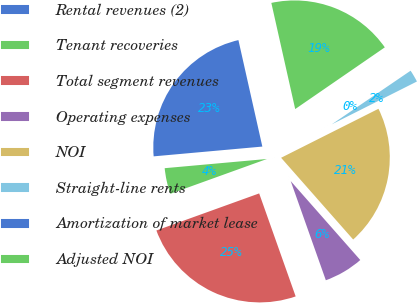<chart> <loc_0><loc_0><loc_500><loc_500><pie_chart><fcel>Rental revenues (2)<fcel>Tenant recoveries<fcel>Total segment revenues<fcel>Operating expenses<fcel>NOI<fcel>Straight-line rents<fcel>Amortization of market lease<fcel>Adjusted NOI<nl><fcel>22.91%<fcel>4.08%<fcel>24.91%<fcel>6.08%<fcel>20.92%<fcel>2.09%<fcel>0.09%<fcel>18.92%<nl></chart> 